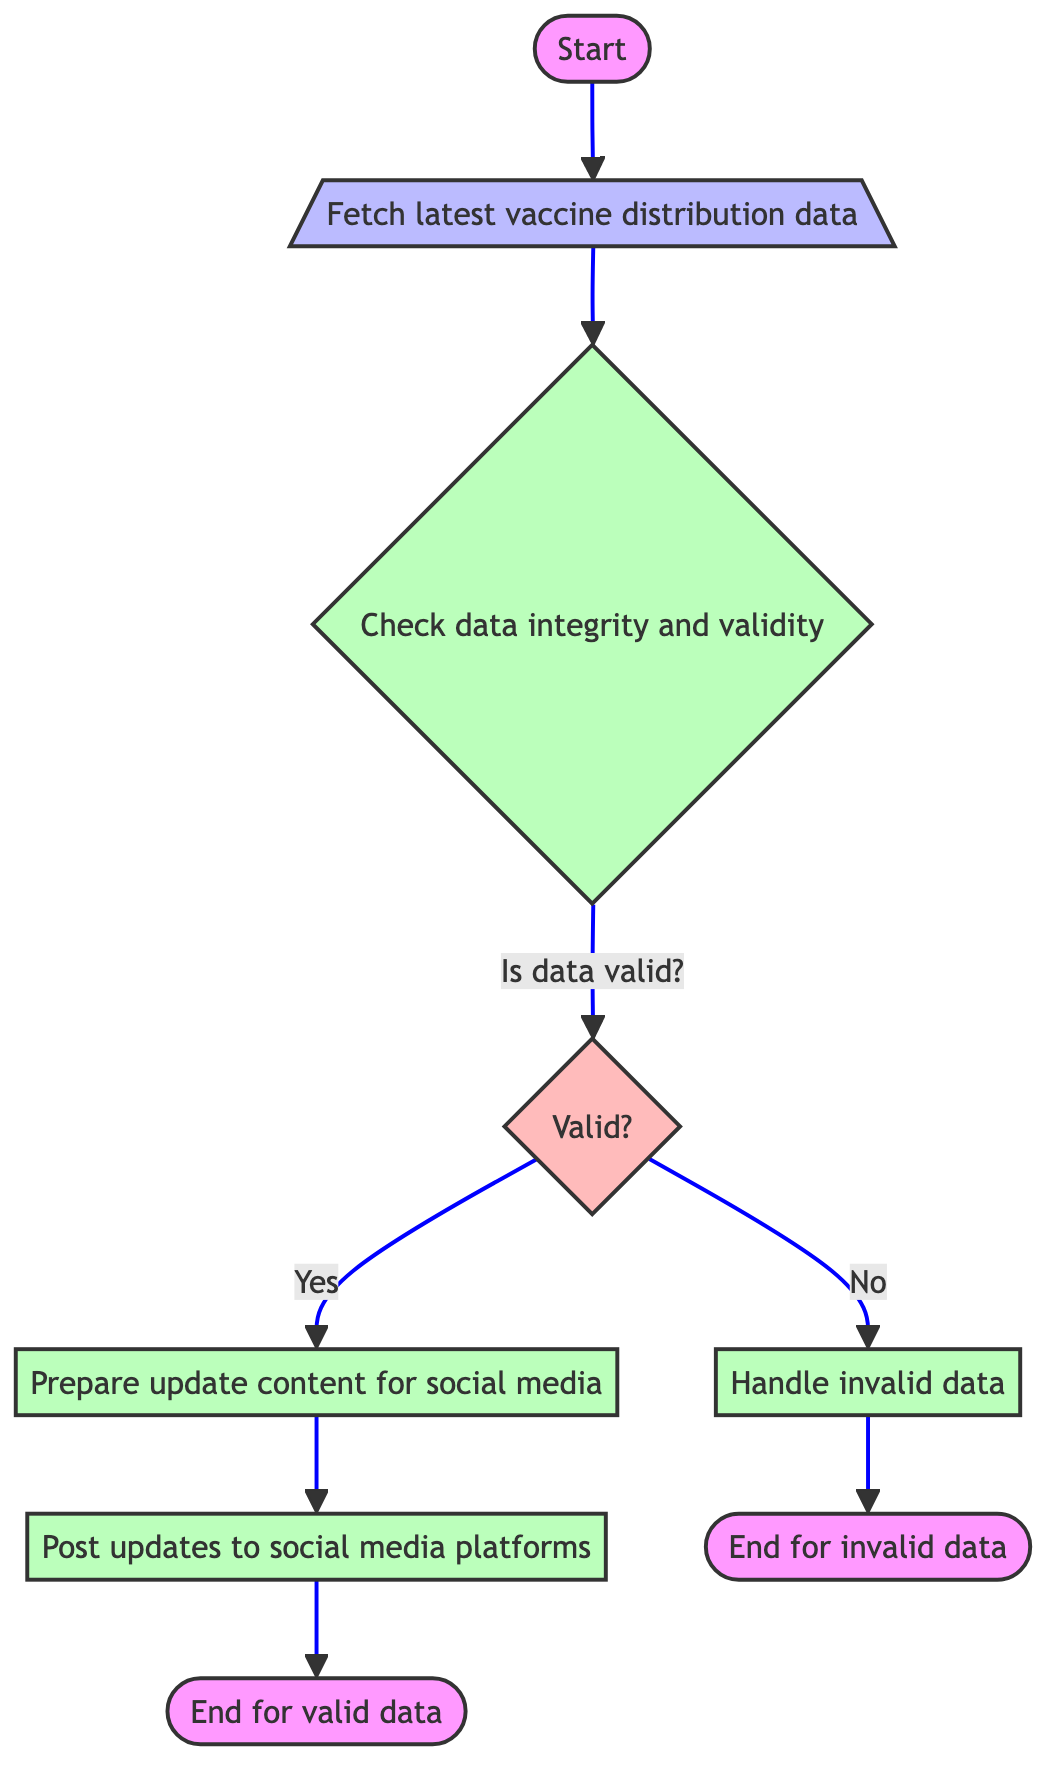What is the first step in the function? The first step in the function is represented by node A, labeled "Start of the function." It indicates the initiation of the process.
Answer: Start of the function How many decision points are present in the diagram? The diagram shows one decision point at node D, which asks if the data is valid. Hence, there is only one decision point in total.
Answer: 1 What happens if the data is not valid? If the data is not valid, it flows from decision node D to process node H, which is labeled "Handle invalid data," indicating the handling of invalid inputs.
Answer: Handle invalid data What is the last step for valid data? The last step for valid data is represented by node G, which concludes the function after successful posting. The label is "End of the function for valid data."
Answer: End of the function for valid data What action occurs after data validation confirms it is valid? Once data validation confirms validity, the flow goes to process node E, which is responsible for preparing content for social media updates.
Answer: Prepare update content for social media What functions are called to post updates to social media? The functions called to post updates to social media are represented collectively in node F and include posting to Twitter, Facebook, and Instagram as three separate functions.
Answer: post to twitter, post to facebook, post to instagram 